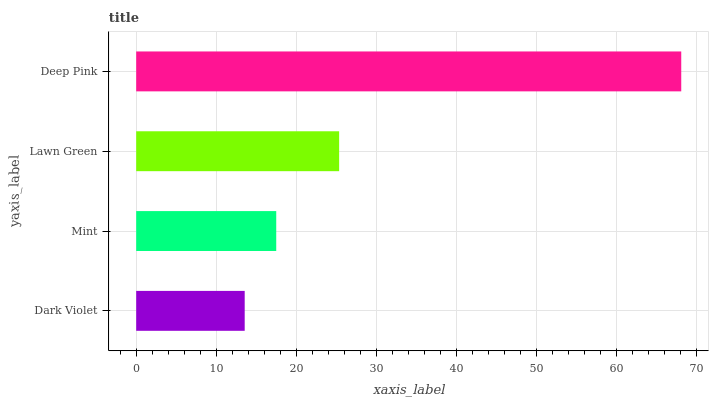Is Dark Violet the minimum?
Answer yes or no. Yes. Is Deep Pink the maximum?
Answer yes or no. Yes. Is Mint the minimum?
Answer yes or no. No. Is Mint the maximum?
Answer yes or no. No. Is Mint greater than Dark Violet?
Answer yes or no. Yes. Is Dark Violet less than Mint?
Answer yes or no. Yes. Is Dark Violet greater than Mint?
Answer yes or no. No. Is Mint less than Dark Violet?
Answer yes or no. No. Is Lawn Green the high median?
Answer yes or no. Yes. Is Mint the low median?
Answer yes or no. Yes. Is Dark Violet the high median?
Answer yes or no. No. Is Lawn Green the low median?
Answer yes or no. No. 